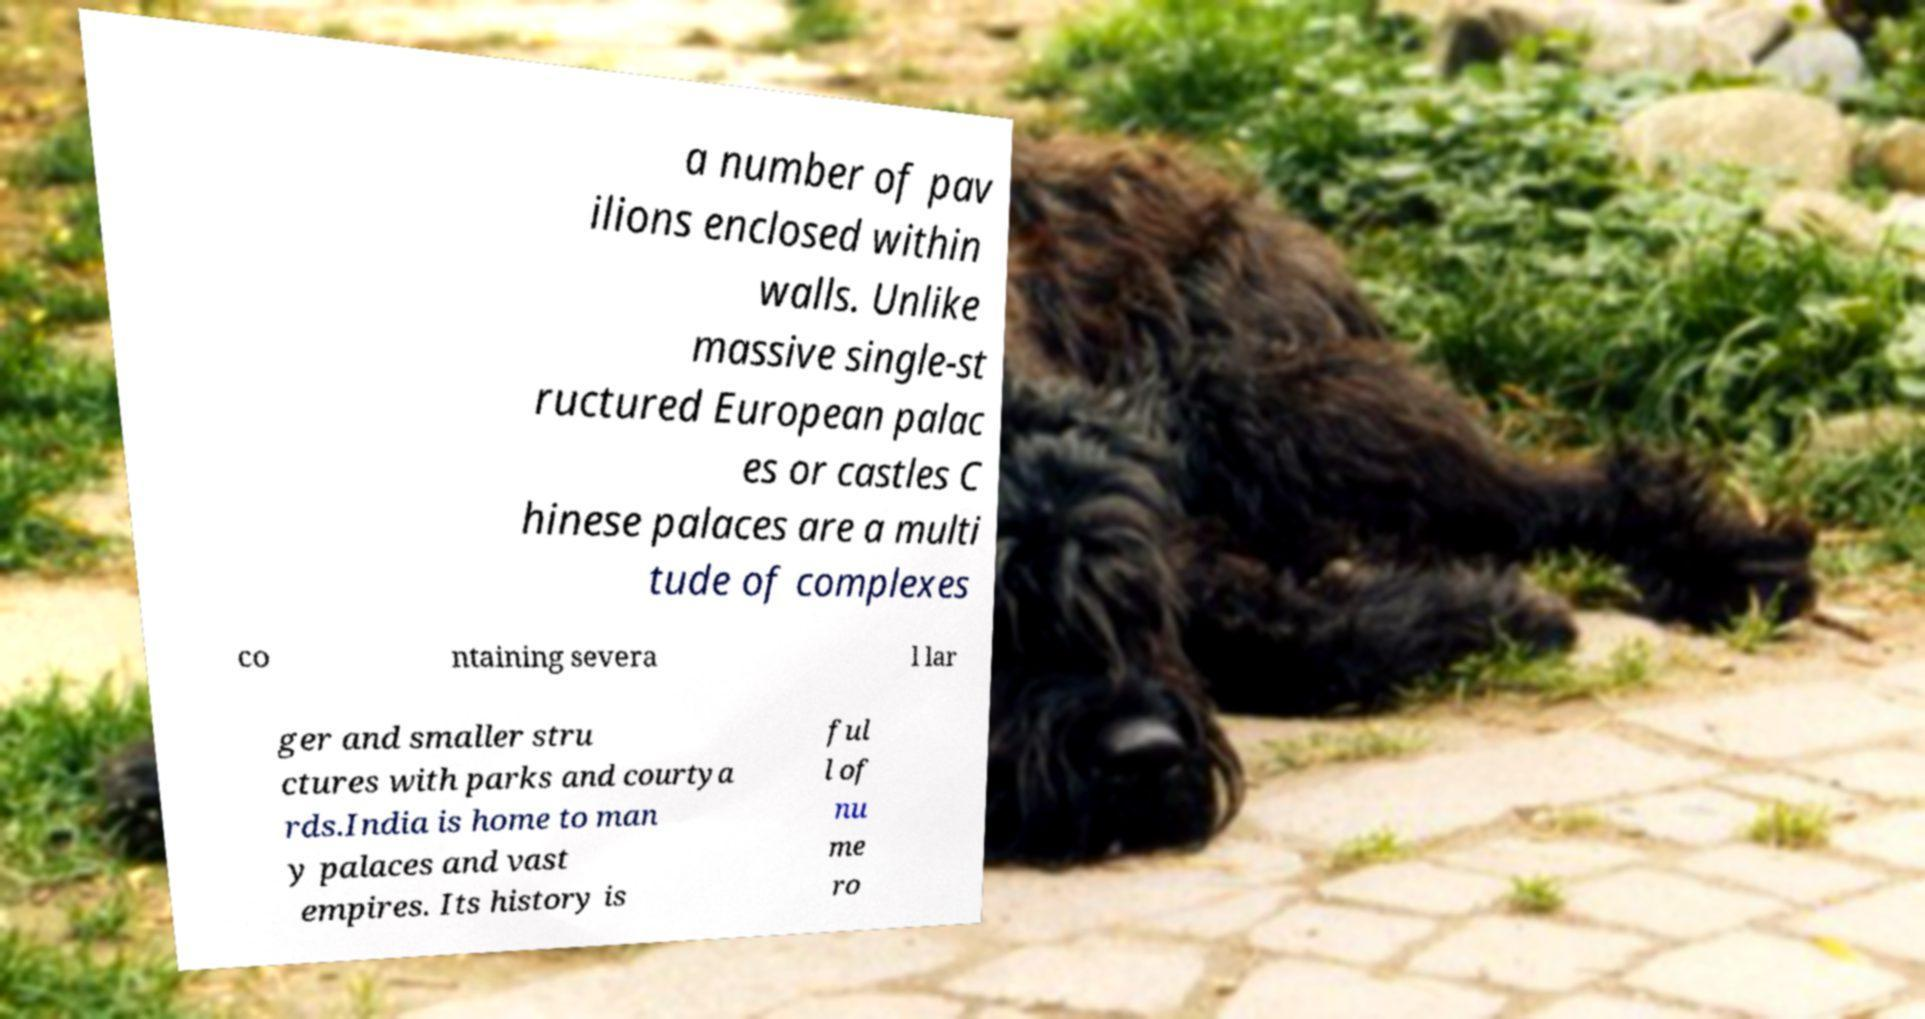Could you extract and type out the text from this image? a number of pav ilions enclosed within walls. Unlike massive single-st ructured European palac es or castles C hinese palaces are a multi tude of complexes co ntaining severa l lar ger and smaller stru ctures with parks and courtya rds.India is home to man y palaces and vast empires. Its history is ful l of nu me ro 